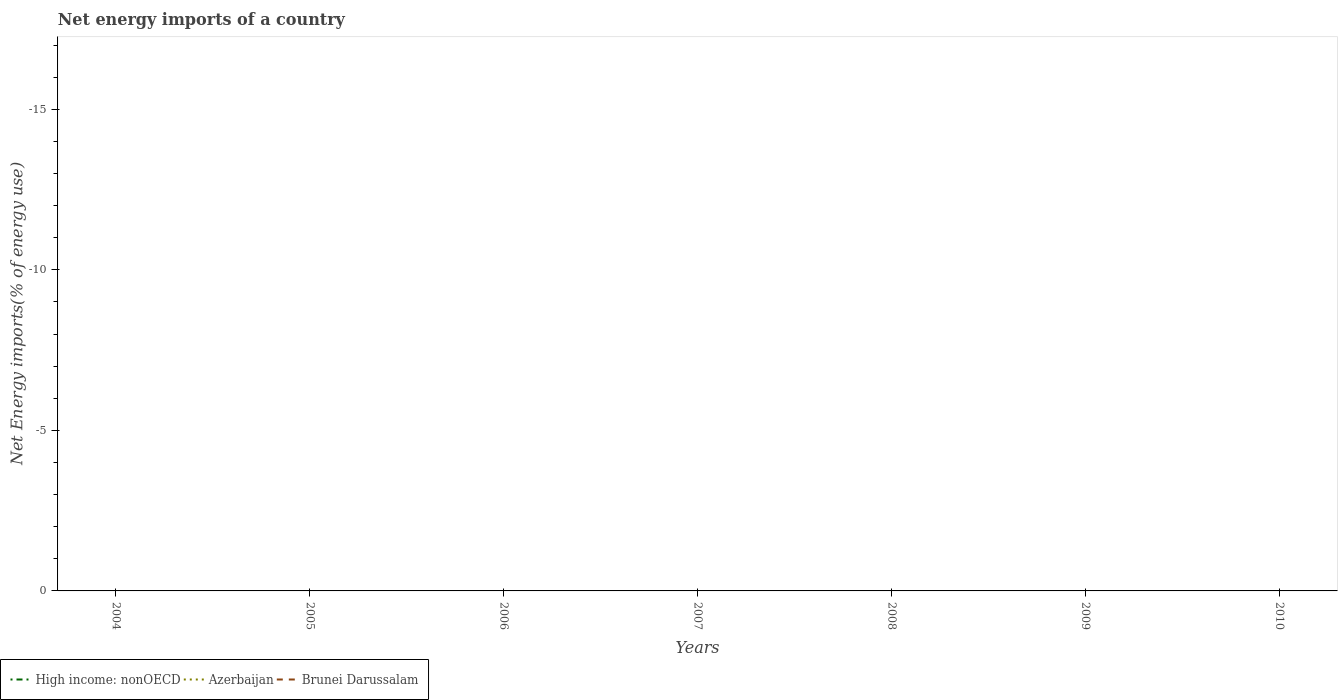How many different coloured lines are there?
Ensure brevity in your answer.  0. Is the number of lines equal to the number of legend labels?
Provide a short and direct response. No. What is the difference between the highest and the lowest net energy imports in Azerbaijan?
Your answer should be very brief. 0. Is the net energy imports in Brunei Darussalam strictly greater than the net energy imports in High income: nonOECD over the years?
Your answer should be very brief. Yes. How many lines are there?
Offer a terse response. 0. How many years are there in the graph?
Keep it short and to the point. 7. Are the values on the major ticks of Y-axis written in scientific E-notation?
Your answer should be very brief. No. Does the graph contain any zero values?
Provide a short and direct response. Yes. Where does the legend appear in the graph?
Your response must be concise. Bottom left. How are the legend labels stacked?
Make the answer very short. Horizontal. What is the title of the graph?
Ensure brevity in your answer.  Net energy imports of a country. What is the label or title of the X-axis?
Your answer should be very brief. Years. What is the label or title of the Y-axis?
Offer a very short reply. Net Energy imports(% of energy use). What is the Net Energy imports(% of energy use) of High income: nonOECD in 2004?
Your answer should be very brief. 0. What is the Net Energy imports(% of energy use) in High income: nonOECD in 2005?
Provide a succinct answer. 0. What is the Net Energy imports(% of energy use) of Brunei Darussalam in 2005?
Make the answer very short. 0. What is the Net Energy imports(% of energy use) in Brunei Darussalam in 2006?
Provide a short and direct response. 0. What is the Net Energy imports(% of energy use) of Azerbaijan in 2007?
Your answer should be very brief. 0. What is the Net Energy imports(% of energy use) of Brunei Darussalam in 2007?
Provide a short and direct response. 0. What is the Net Energy imports(% of energy use) in High income: nonOECD in 2008?
Ensure brevity in your answer.  0. What is the Net Energy imports(% of energy use) in Brunei Darussalam in 2008?
Ensure brevity in your answer.  0. What is the Net Energy imports(% of energy use) of Brunei Darussalam in 2009?
Your answer should be compact. 0. What is the Net Energy imports(% of energy use) in High income: nonOECD in 2010?
Provide a succinct answer. 0. What is the Net Energy imports(% of energy use) of Brunei Darussalam in 2010?
Give a very brief answer. 0. What is the total Net Energy imports(% of energy use) in High income: nonOECD in the graph?
Give a very brief answer. 0. What is the total Net Energy imports(% of energy use) in Brunei Darussalam in the graph?
Your answer should be compact. 0. 